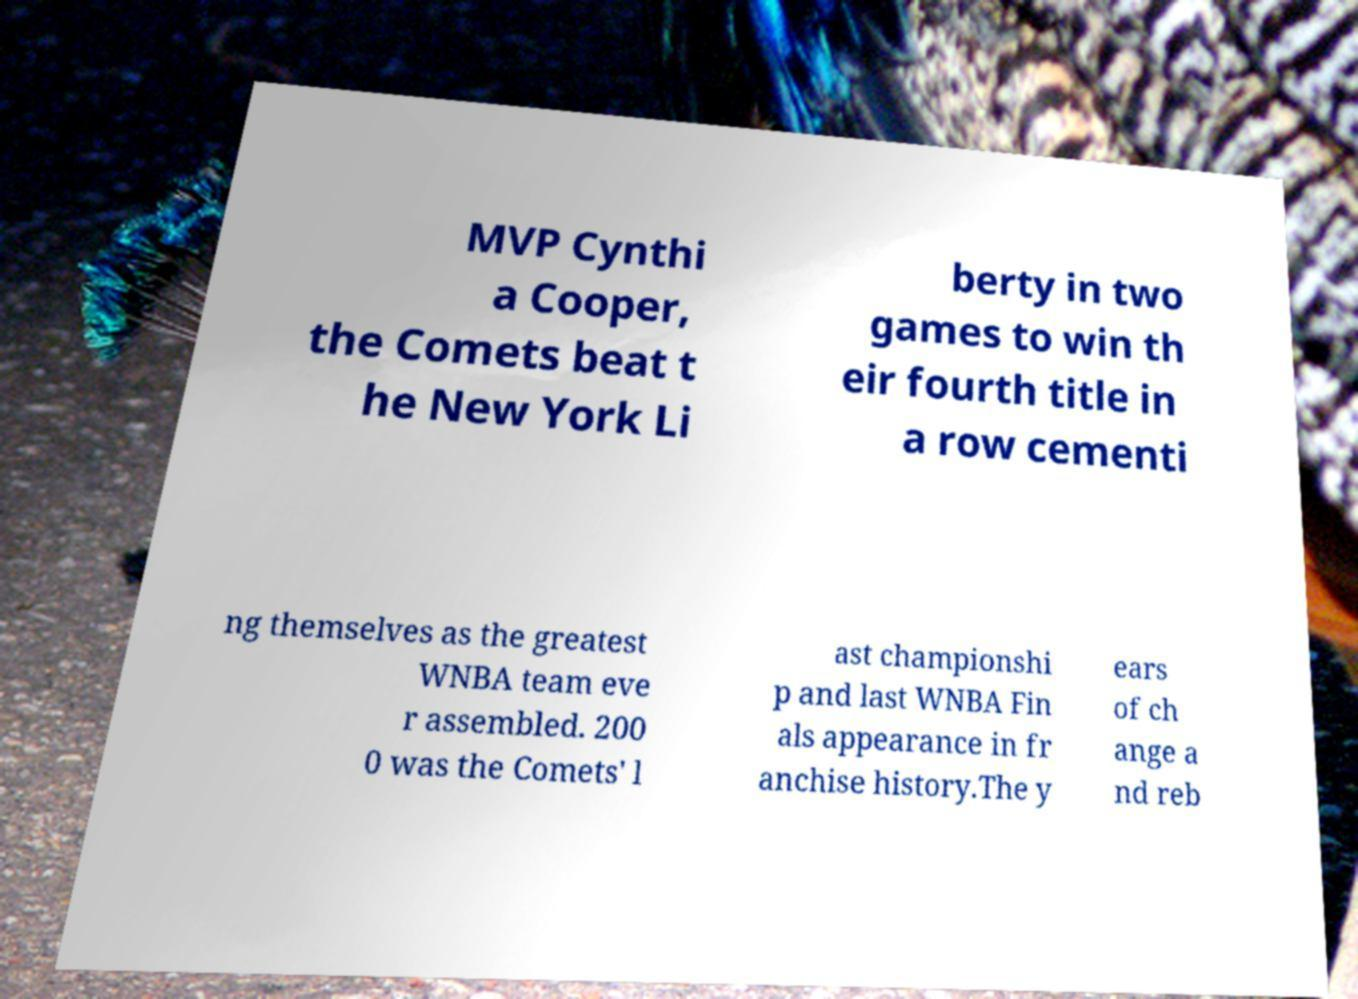What messages or text are displayed in this image? I need them in a readable, typed format. MVP Cynthi a Cooper, the Comets beat t he New York Li berty in two games to win th eir fourth title in a row cementi ng themselves as the greatest WNBA team eve r assembled. 200 0 was the Comets' l ast championshi p and last WNBA Fin als appearance in fr anchise history.The y ears of ch ange a nd reb 